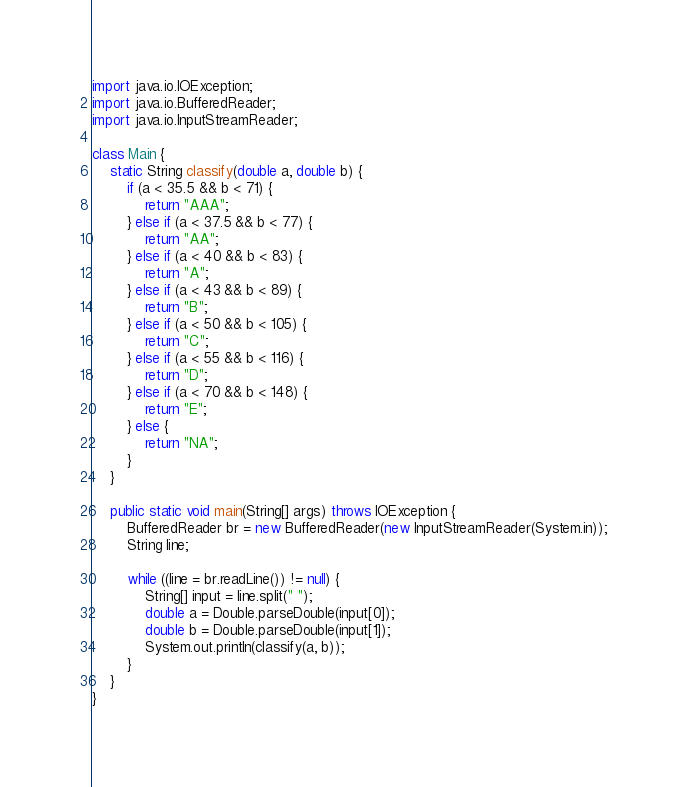<code> <loc_0><loc_0><loc_500><loc_500><_Java_>import java.io.IOException;
import java.io.BufferedReader;
import java.io.InputStreamReader;

class Main {
    static String classify(double a, double b) {
        if (a < 35.5 && b < 71) {
            return "AAA";
        } else if (a < 37.5 && b < 77) {
            return "AA";
        } else if (a < 40 && b < 83) {
            return "A";
        } else if (a < 43 && b < 89) {
            return "B";
        } else if (a < 50 && b < 105) {
            return "C";
        } else if (a < 55 && b < 116) {
            return "D";
        } else if (a < 70 && b < 148) {
            return "E";
        } else {
            return "NA";
        }
    }

    public static void main(String[] args) throws IOException {
        BufferedReader br = new BufferedReader(new InputStreamReader(System.in));
        String line;

        while ((line = br.readLine()) != null) {
            String[] input = line.split(" ");
            double a = Double.parseDouble(input[0]);
            double b = Double.parseDouble(input[1]);
            System.out.println(classify(a, b));
        }
    }
}
</code> 